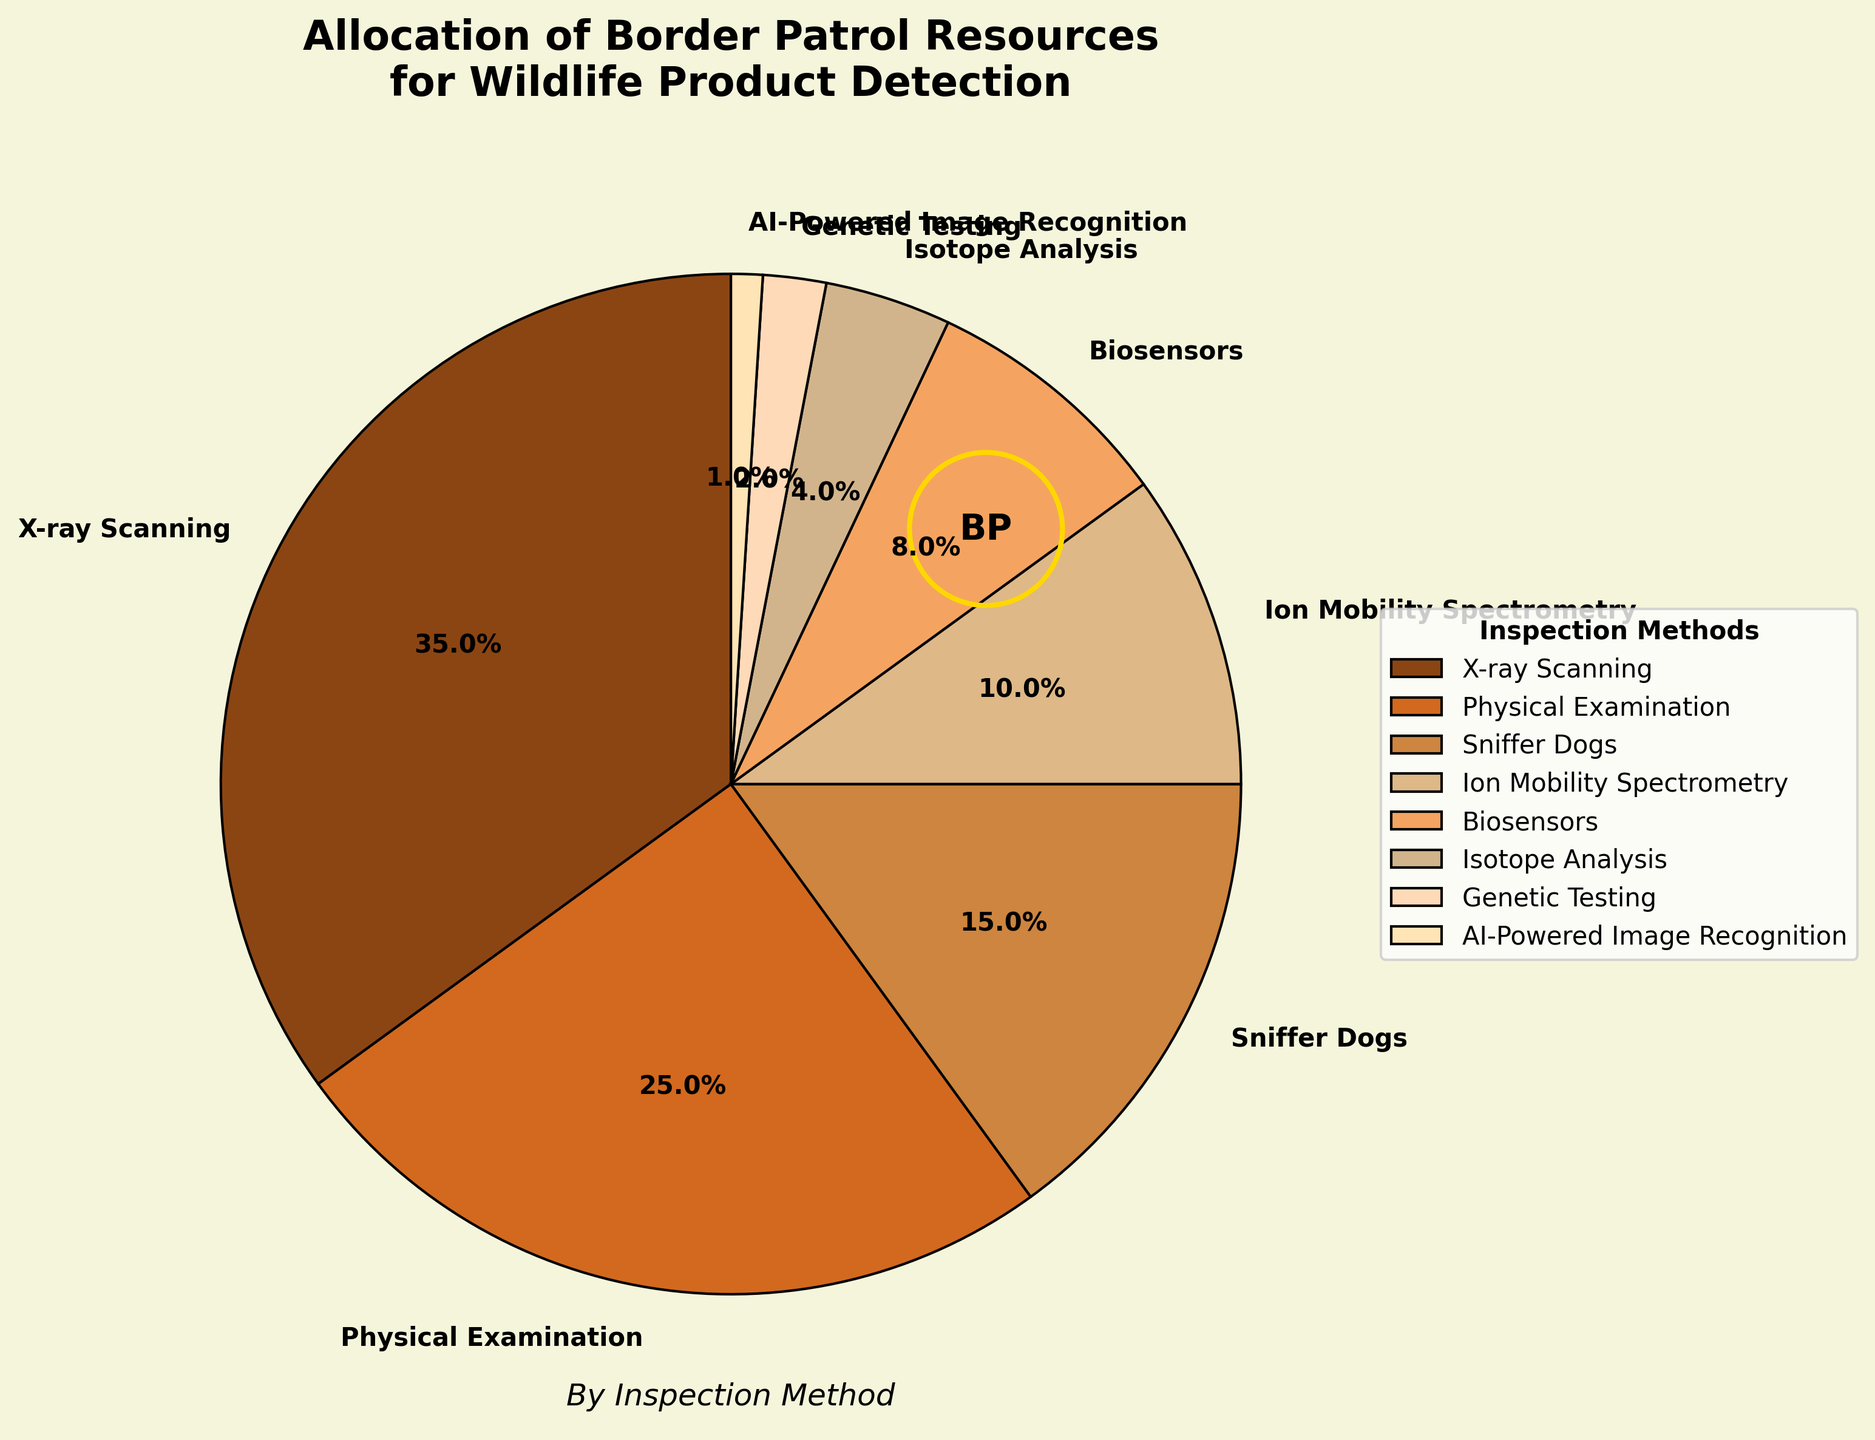What is the most used inspection method for wildlife product detection according to the chart? The pie chart shows that the largest wedge corresponds to "X-ray Scanning," which occupies 35% of the total allocation.
Answer: X-ray Scanning How much more percentage is allocated to Physical Examination compared to AI-Powered Image Recognition? The percentage allocated to Physical Examination is 25% and to AI-Powered Image Recognition is 1%. The difference is calculated as 25% - 1% = 24%.
Answer: 24% Which two inspection methods together make up exactly 50% of the resource allocation? The pie chart indicates that "X-ray Scanning" accounts for 35% and "Physical Examination" takes 25%. Summing these, 35% + 25% = 60%, which exceeds 50%. Next, "Sniffer Dogs" has 15%, and adding "X-ray Scanning" gives 35% + 15% = 50%. Thus, "X-ray Scanning" and "Sniffer Dogs" together make up 50%.
Answer: X-ray Scanning and Sniffer Dogs What is the combined percentage of resources allocated to Biosensors and Isotope Analysis? The chart shows that Biosensors have 8% and Isotope Analysis has 4%. Combining these, 8% + 4% = 12%.
Answer: 12% Which inspection method is allocated the least resources? The pie chart indicates that "AI-Powered Image Recognition" has the smallest wedge at 1%.
Answer: AI-Powered Image Recognition How does the allocation for Genetic Testing compare to that for Sniffer Dogs in terms of percentage? According to the pie chart, Genetic Testing is allocated 2%, while Sniffer Dogs are allocated 15%. Genetic Testing is 15% - 2% = 13% less than Sniffer Dogs.
Answer: 13% less What are the percentages allocated to Ion Mobility Spectrometry and Genetic Testing combined? Ion Mobility Spectrometry accounts for 10% and Genetic Testing for 2%. Summing these, 10% + 2% = 12%.
Answer: 12% Which inspection method has a higher allocation: Biosensors or Isotope Analysis, and by how much? The percentage for Biosensors is 8%, and for Isotope Analysis, it is 4%. The difference is 8% - 4% = 4%.
Answer: 4% more for Biosensors If we combine the percentages of all methods excluding Physical Examination and Sniffer Dogs, what would the total be? Excluding Physical Examination (25%) and Sniffer Dogs (15%), the remaining methods are: X-ray Scanning (35%), Ion Mobility Spectrometry (10%), Biosensors (8%), Isotope Analysis (4%), Genetic Testing (2%), and AI-Powered Image Recognition (1%). Summing these: 35% + 10% + 8% + 4% + 2% + 1% = 60%.
Answer: 60% What visual element is used to highlight the border patrol's involvement in the detection process? The pie chart includes a circle with "BP" in the center, encircled by a gold-colored border, representing the border patrol's involvement.
Answer: Circle with "BP" 